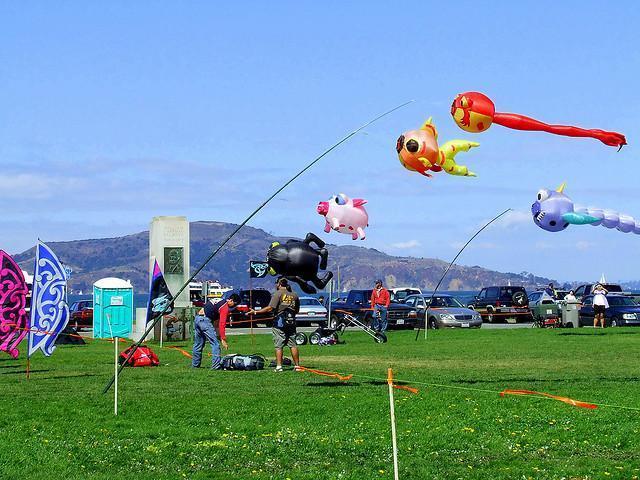How many kites are in the picture?
Give a very brief answer. 4. 